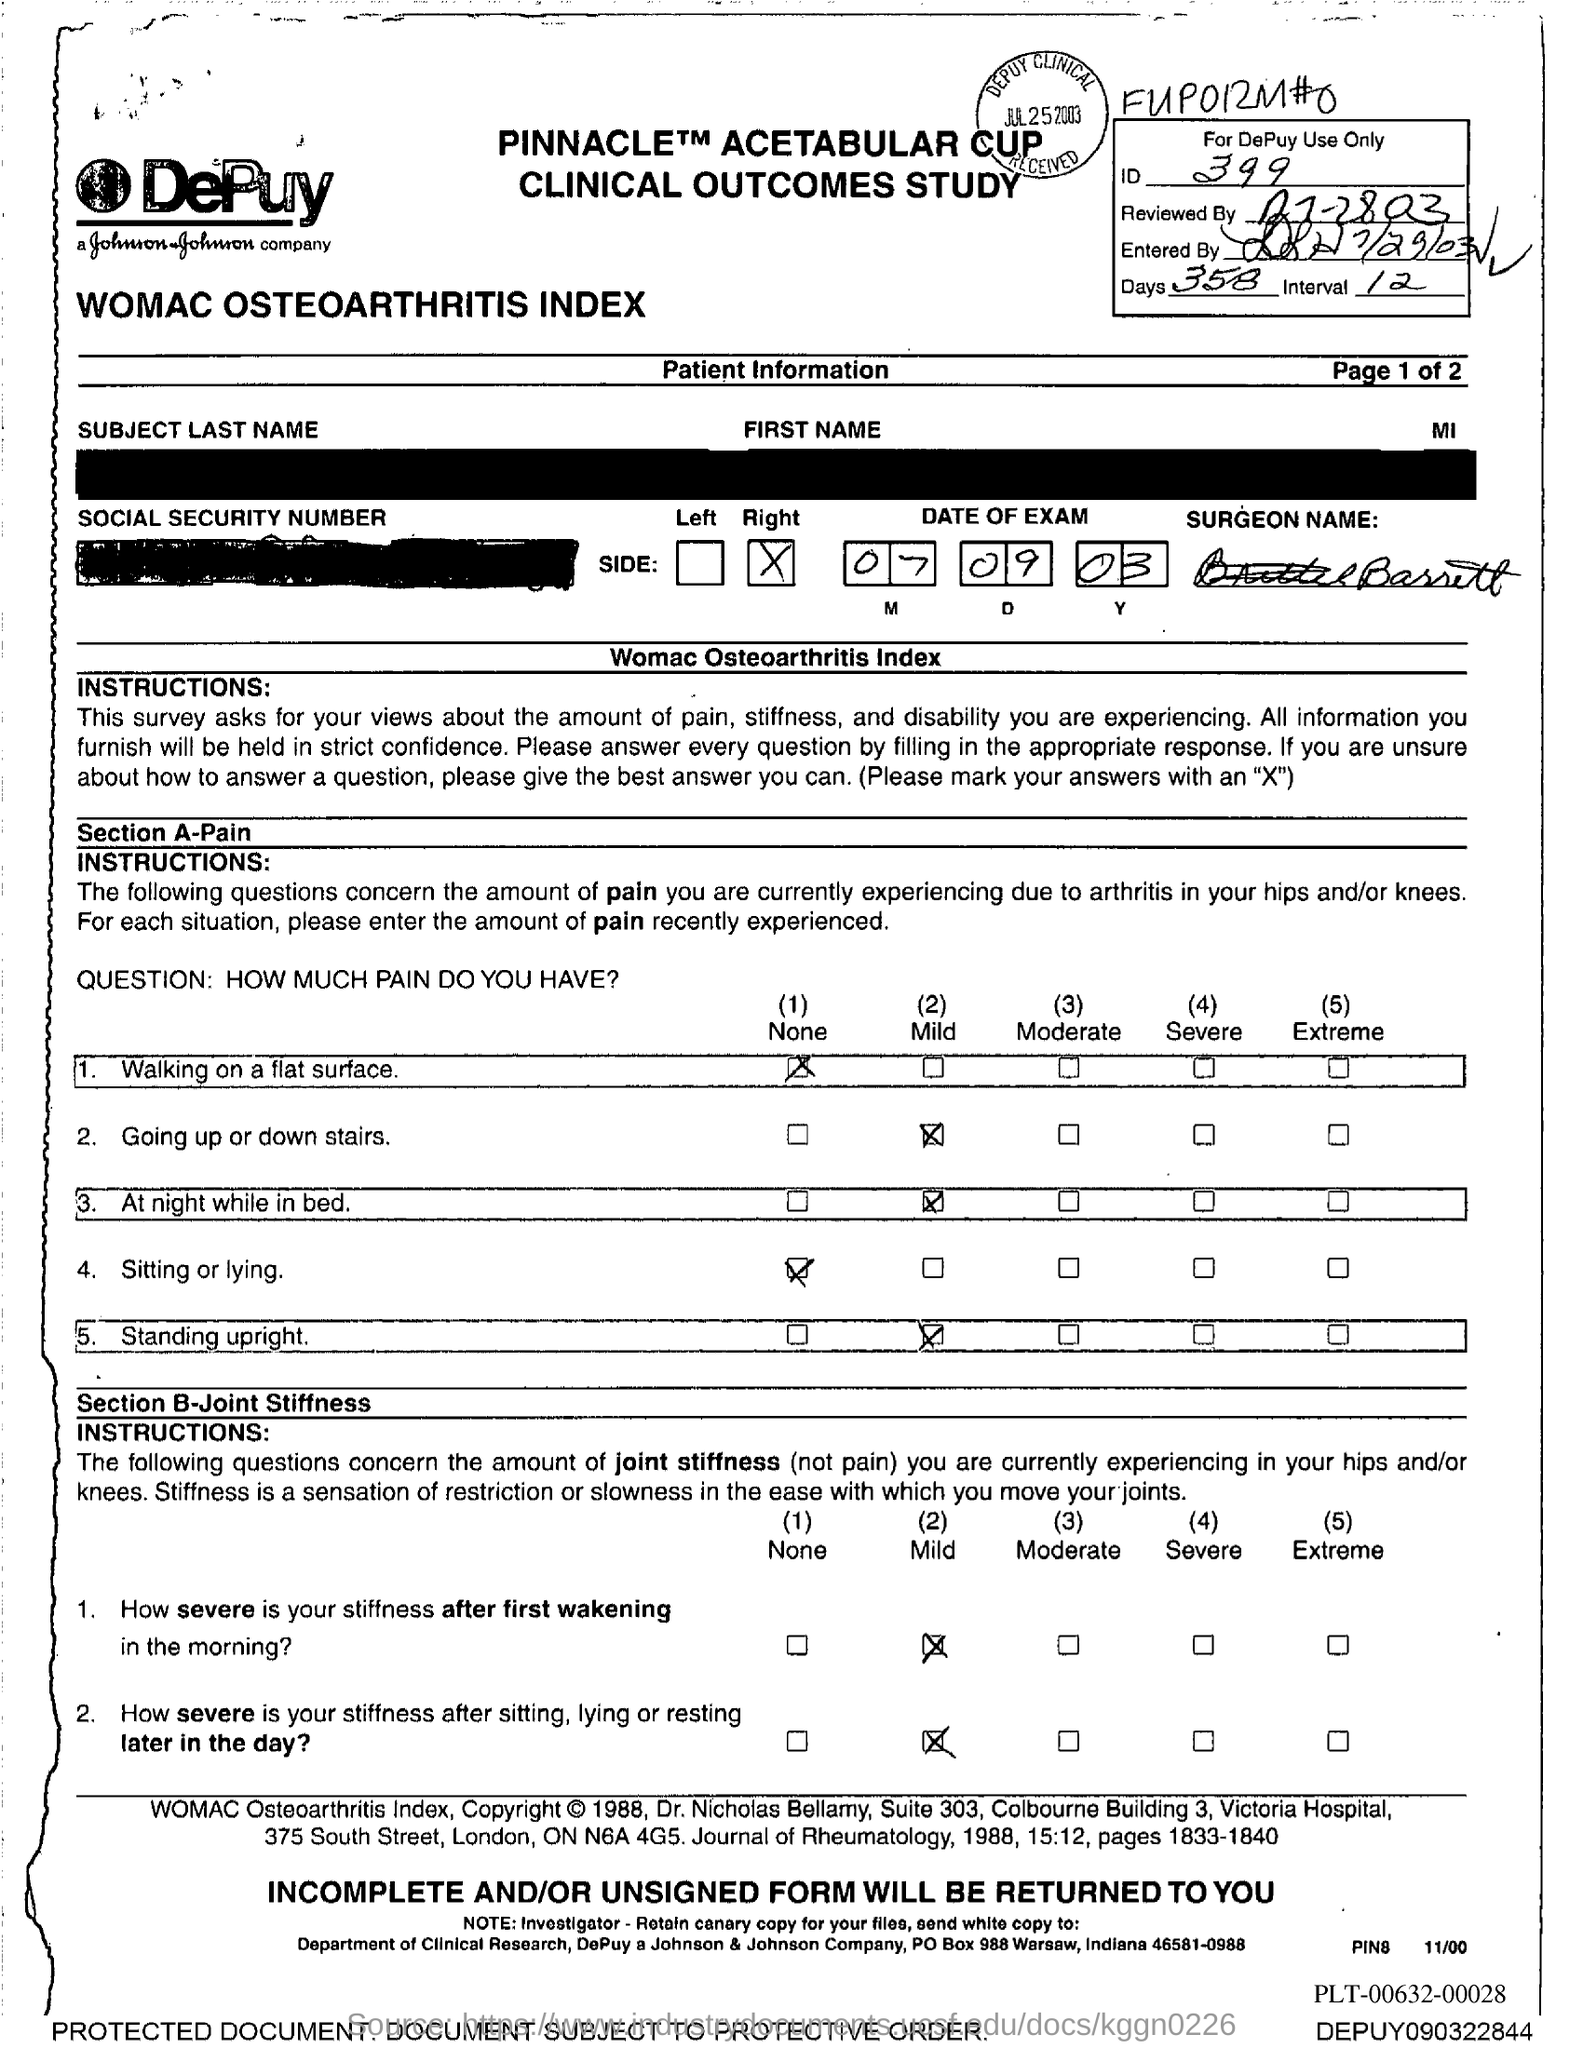What is the no of days given in the form?
Offer a very short reply. 358. What is the interval period mentioned in the form?
Provide a short and direct response. 12. What is the ID mentioned in the form?
Keep it short and to the point. 399. What is the date of exam given in the form?
Your answer should be compact. 07 09 03. What is the surgeon name mentioned in the form?
Offer a very short reply. Barrett. 